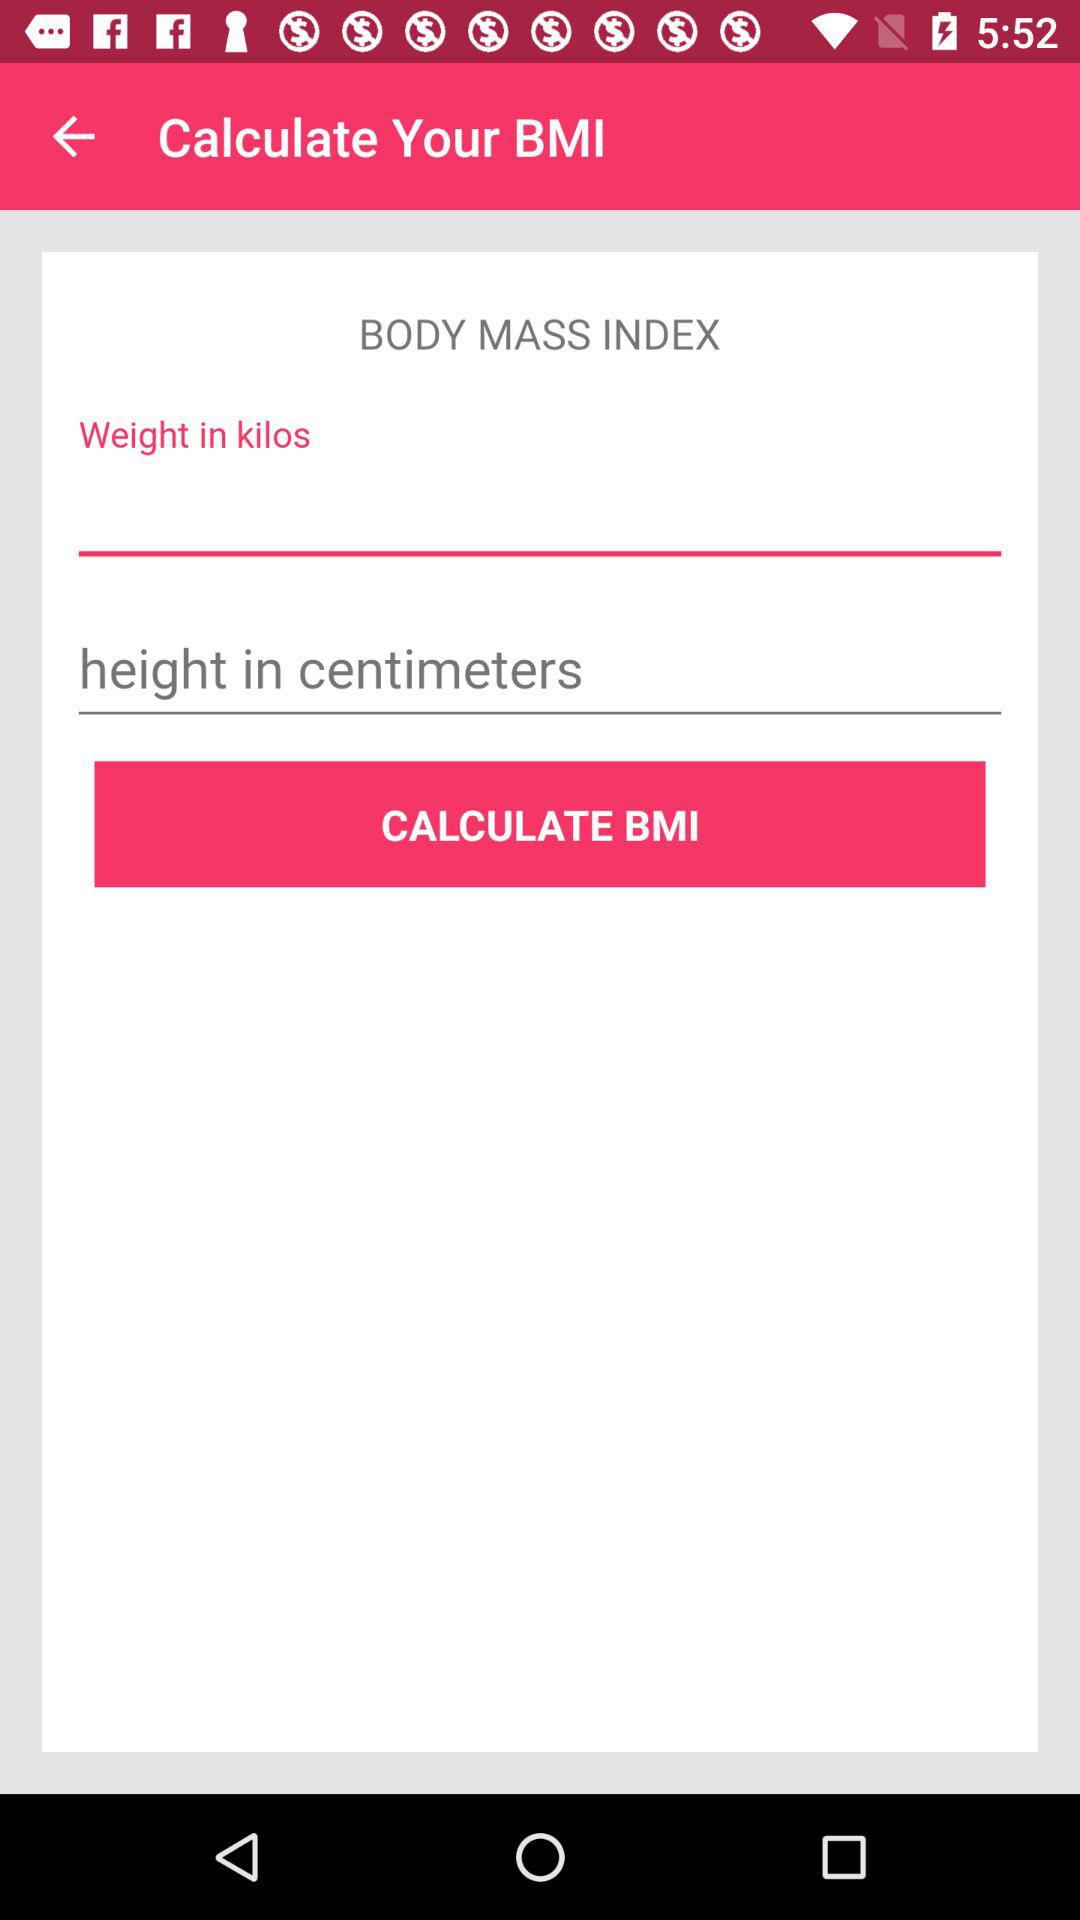What is the given unit of weight? The given unit of weight is kilograms. 